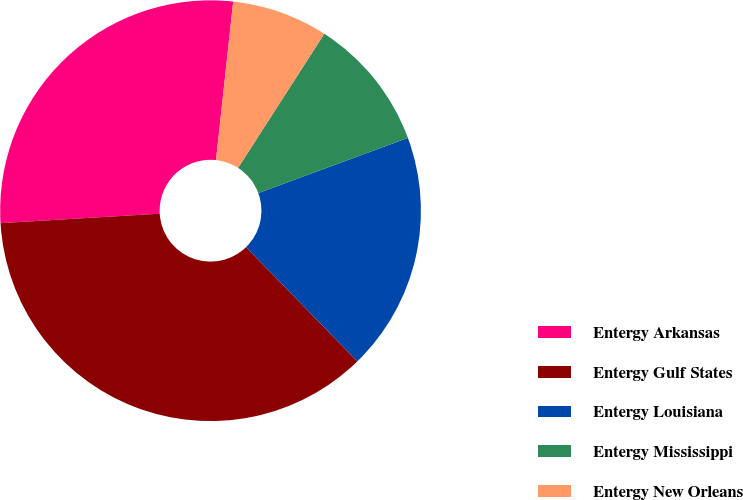Convert chart to OTSL. <chart><loc_0><loc_0><loc_500><loc_500><pie_chart><fcel>Entergy Arkansas<fcel>Entergy Gulf States<fcel>Entergy Louisiana<fcel>Entergy Mississippi<fcel>Entergy New Orleans<nl><fcel>27.66%<fcel>36.35%<fcel>18.33%<fcel>10.28%<fcel>7.38%<nl></chart> 